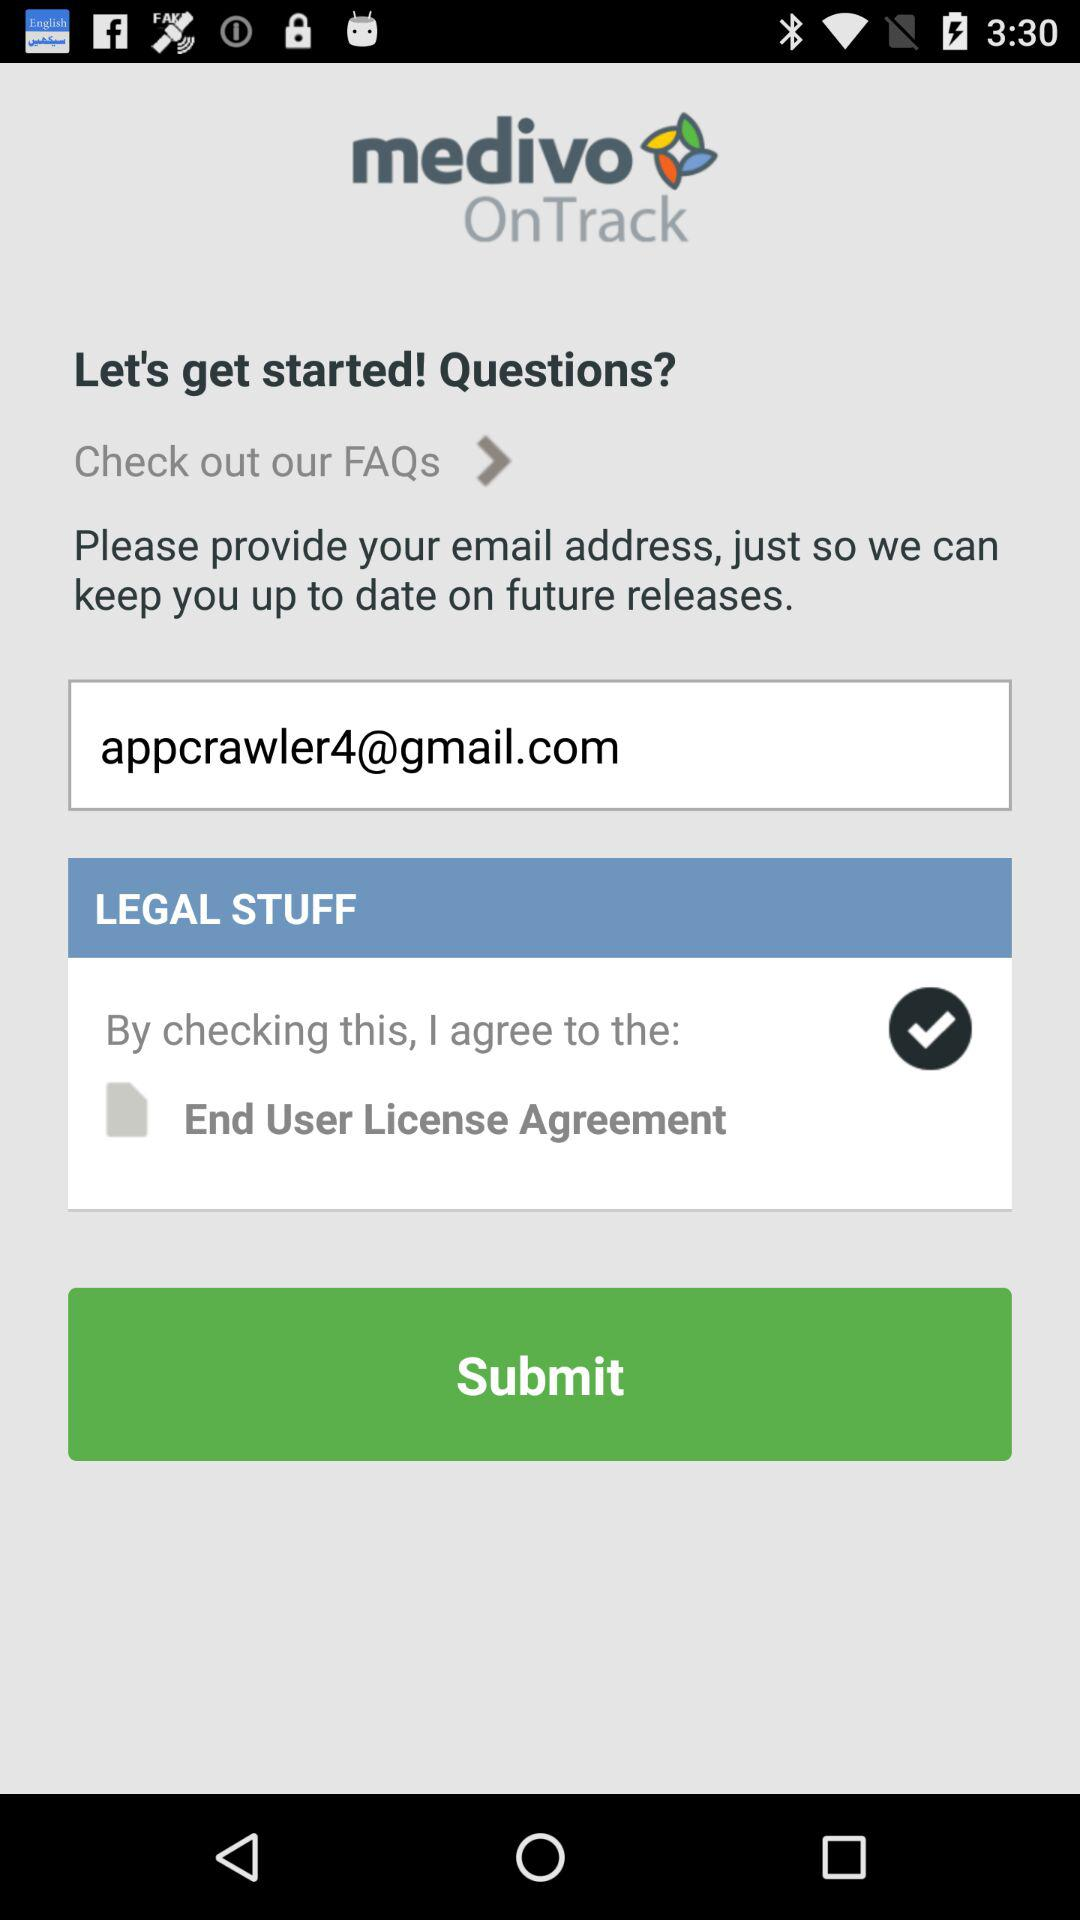What is the name of the application? The name of the application is "medivo OnTrack". 